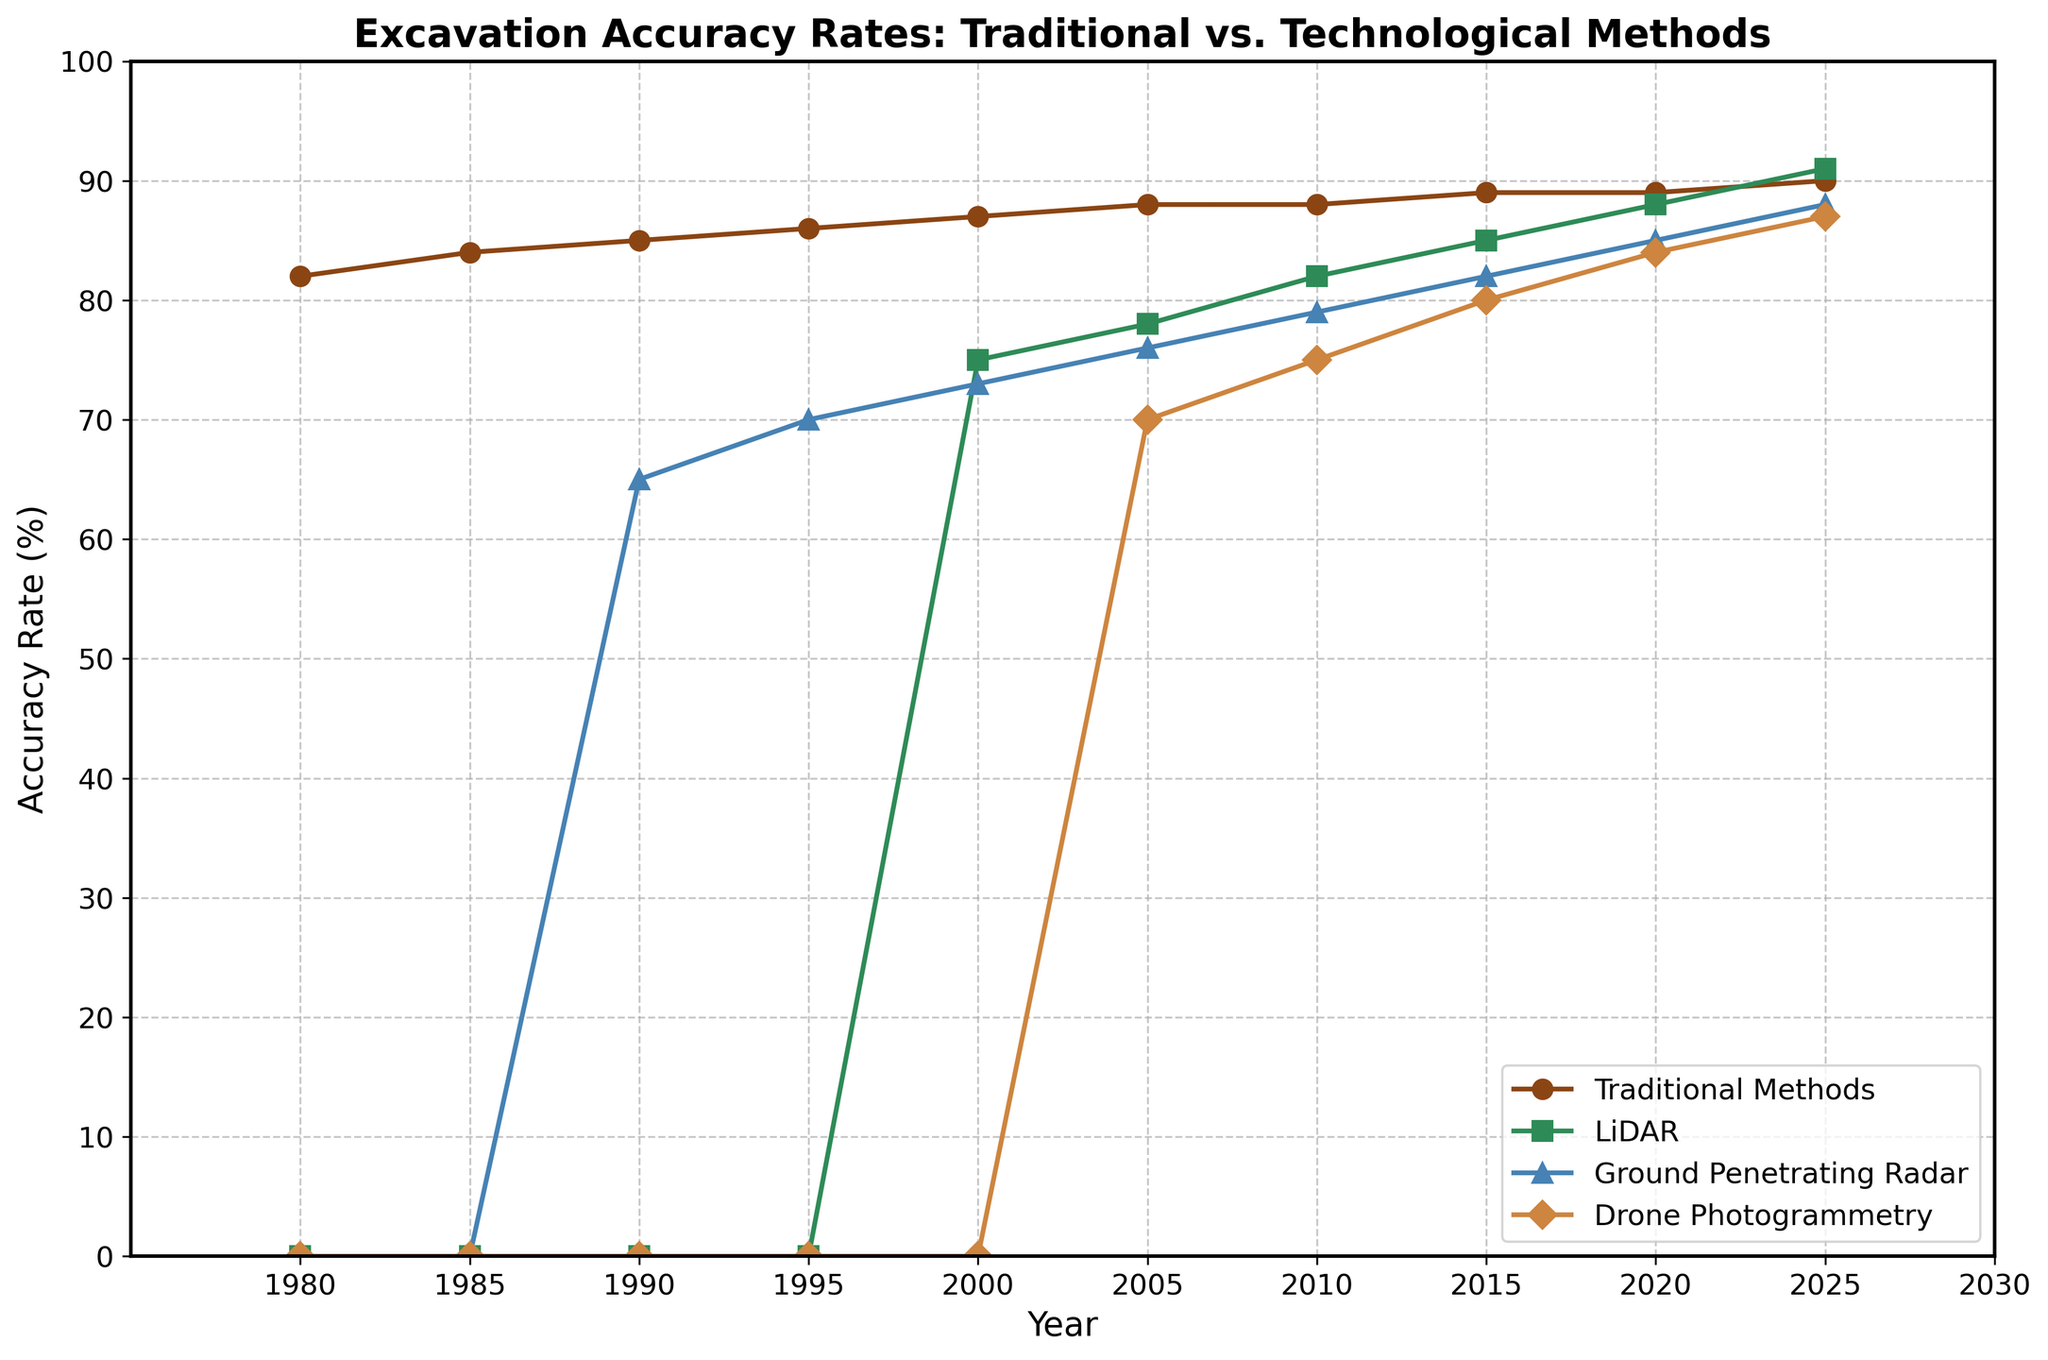How has the accuracy rate of traditional methods changed from 1980 to 2025? To determine the change, subtract the accuracy rate in 1980 from the rate in 2025. The rate was 82% in 1980 and 90% in 2025. The change is 90% - 82% = 8%.
Answer: 8% Which method showed the most rapid improvement between 1990 and 2025? Compare the difference in accuracy rates for each method over the period. LiDAR went from 0% to 91% (91% increase), Ground Penetrating Radar from 65% to 88% (23% increase), and Drone Photogrammetry from 0% to 87% (87% increase). LiDAR had the most rapid improvement with a 91% increase.
Answer: LiDAR In what year did Drone Photogrammetry first appear in the chart? Check each year's data to see when Drone Photogrammetry first shows a non-zero accuracy rate. It first appears in 2005 with a rate of 70%.
Answer: 2005 Which method had the highest accuracy rate in 2020, and what was that rate? Look at the accuracy rates for all methods in 2020. LiDAR had the highest rate at 88%.
Answer: LiDAR, 88% What was the average accuracy rate of Ground Penetrating Radar over the period shown? Sum the accuracy rates for Ground Penetrating Radar from 1990 to 2025 and divide by the number of years it has data. The rates are 65, 70, 73, 76, 79, 82, 85, and 88. The sum is 618, and there are 8 data points, so the average is 618 / 8 = 77.25%.
Answer: 77.25% Which two methods had equal accuracy rates, and what were the values, in any of the years shown? Compare the accuracy rates for all methods in each year. In 2000, LiDAR and Ground Penetrating Radar both had an accuracy rate of 75%.
Answer: LiDAR and Ground Penetrating Radar, 75% What is the difference between the accuracy rates of Traditional Methods and Drone Photogrammetry in 2025? Subtract the accuracy rate of Drone Photogrammetry from that of Traditional Methods in 2025. Traditional Methods had 90%, and Drone Photogrammetry had 87%. The difference is 90% - 87% = 3%.
Answer: 3% Which method showed a consistent linear increase in accuracy rate over the entire period? Examine each method to see if their increases are consistent and linear. Traditional Methods increased steadily from 82% to 90%, showing consistent linear growth.
Answer: Traditional Methods 